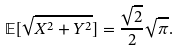Convert formula to latex. <formula><loc_0><loc_0><loc_500><loc_500>\mathbb { E } [ \sqrt { X ^ { 2 } + Y ^ { 2 } } ] = \frac { \sqrt { 2 } } { 2 } \sqrt { \pi } .</formula> 